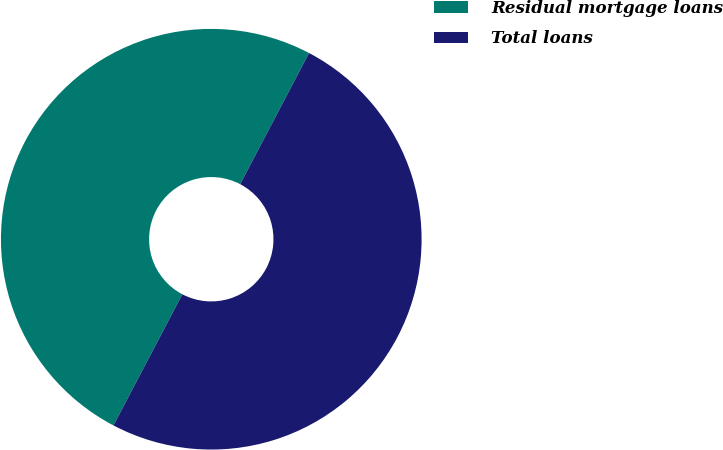Convert chart. <chart><loc_0><loc_0><loc_500><loc_500><pie_chart><fcel>Residual mortgage loans<fcel>Total loans<nl><fcel>50.0%<fcel>50.0%<nl></chart> 